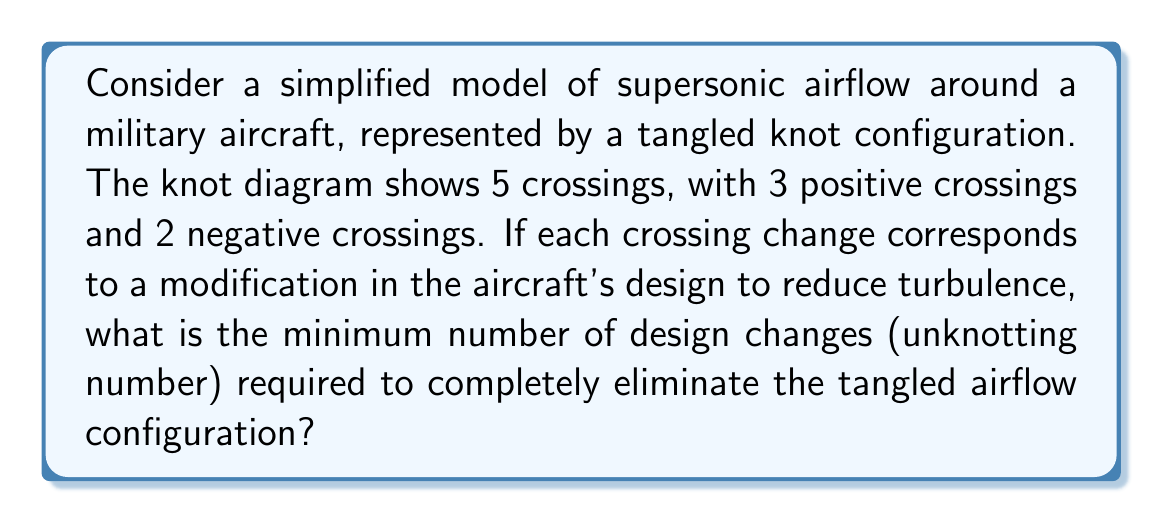Provide a solution to this math problem. To solve this problem, we'll follow these steps:

1. Understand the concept of unknotting number:
   The unknotting number is the minimum number of crossing changes required to transform a given knot into the unknot (trivial knot).

2. Analyze the given information:
   - Total crossings: 5
   - Positive crossings: 3
   - Negative crossings: 2

3. Calculate the writhe of the knot:
   Writhe = (Number of positive crossings) - (Number of negative crossings)
   $$ W = 3 - 2 = 1 $$

4. Apply the unknotting number theorem:
   For any knot K, the unknotting number u(K) satisfies:
   $$ u(K) \geq \frac{|W(K)|}{2} $$
   where W(K) is the writhe of the knot.

5. Calculate the lower bound for the unknotting number:
   $$ u(K) \geq \frac{|1|}{2} = 0.5 $$

6. Since the unknotting number must be an integer, we round up:
   $$ u(K) \geq 1 $$

7. Verify if changing one crossing is sufficient:
   In this case, changing any one of the 5 crossings can unknot the configuration, as it represents a simple overhand knot.

Therefore, the minimum number of design changes required to eliminate the tangled airflow configuration is 1.
Answer: 1 